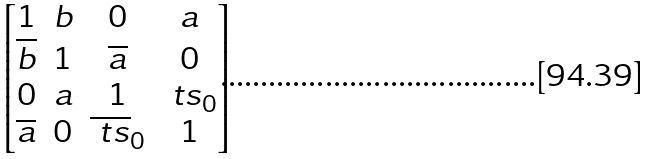<formula> <loc_0><loc_0><loc_500><loc_500>\begin{bmatrix} 1 & b & 0 & a \\ \overline { b } & 1 & \overline { a } & 0 \\ 0 & a & 1 & \ t s _ { 0 } \\ \overline { a } & 0 & \overline { \ t s } _ { 0 } & 1 \end{bmatrix}</formula> 